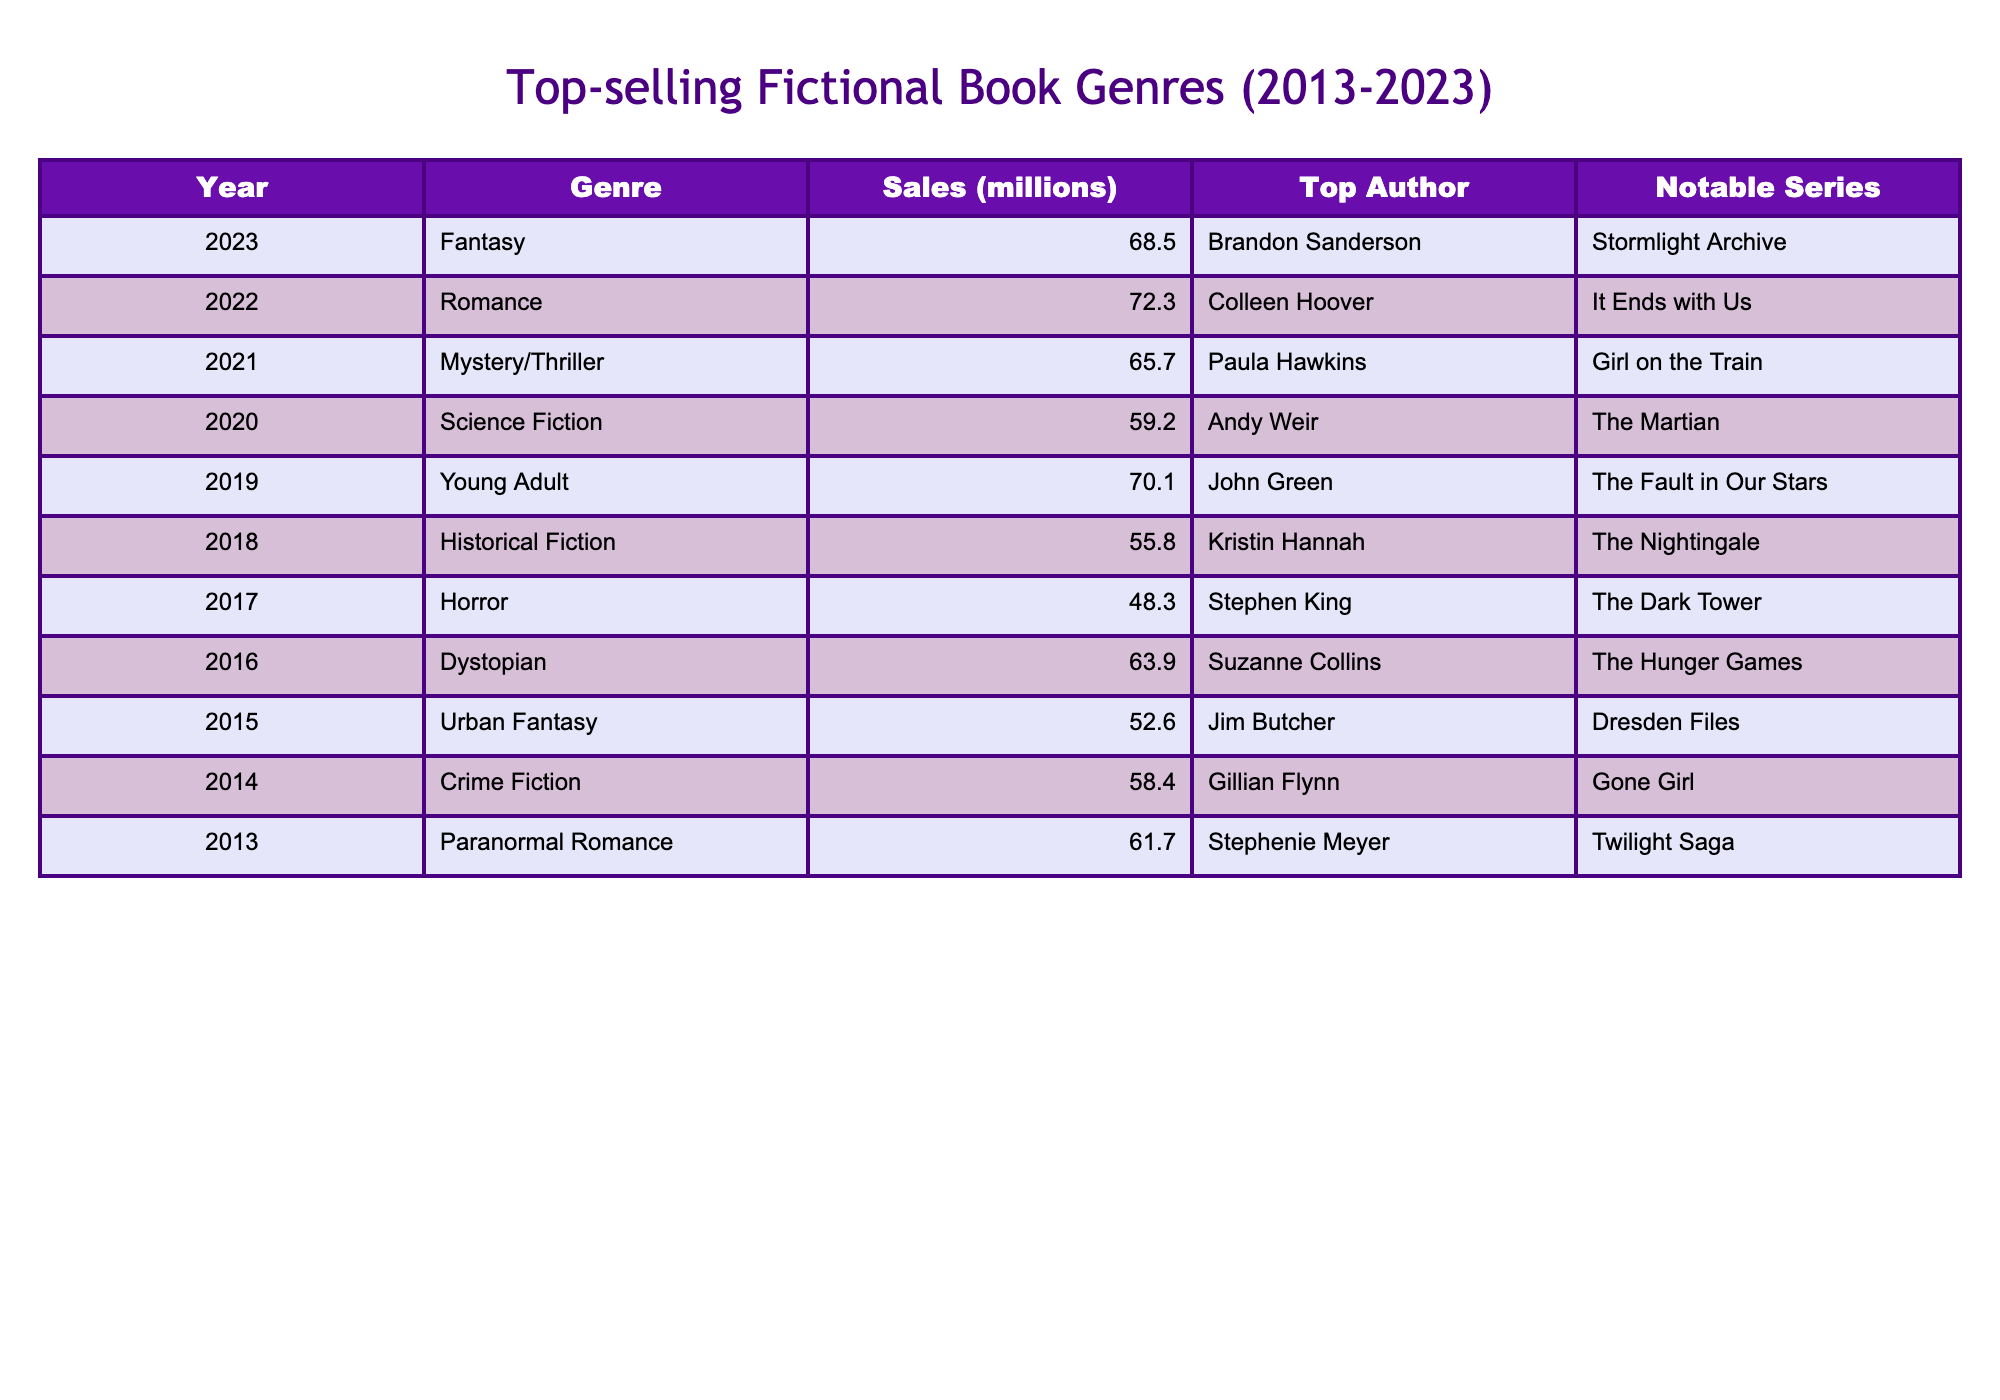What was the top-selling genre in 2023? The table shows that Fantasy was the top-selling genre in 2023 with sales of 68.5 million.
Answer: Fantasy Which genre had the highest sales in 2022? In 2022, Romance had the highest sales at 72.3 million, according to the table.
Answer: Romance How many million copies were sold in total across all years listed? The total sales can be calculated by adding all sales figures: 68.5 + 72.3 + 65.7 + 59.2 + 70.1 + 55.8 + 48.3 + 63.9 + 52.6 + 58.4 + 61.7 = 672.1 million.
Answer: 672.1 million Was there a noticeable increase in sales from 2020 to 2021? Comparing sales from 2020 (59.2 million) to 2021 (65.7 million), there was an increase of 6.5 million. This indicates a noticeable rise.
Answer: Yes Which genre had the lowest sales in the decade? The table indicates that Horror had the lowest sales at 48.3 million in 2017.
Answer: Horror What was the sales difference between the top-selling genre of 2023 and 2021? The difference can be calculated by subtracting 2021 sales (65.7 million) from 2023 sales (68.5 million), resulting in a difference of 2.8 million.
Answer: 2.8 million Which author had the top-selling book in 2019? In 2019, the table shows that John Green was the top author with the genre being Young Adult and sales at 70.1 million.
Answer: John Green What is the median sales figure for the years presented in the table? To find the median, we list the sales figures: [48.3, 52.6, 55.8, 59.2, 61.7, 63.9, 65.7, 68.5, 70.1, 72.3], which has 10 values. The median is the average of the 5th and 6th values: (61.7 + 63.9)/2 = 62.8 million.
Answer: 62.8 million Which years had sales above 60 million? The years with sales above 60 million are 2013, 2014, 2016, 2019, 2021, 2022, and 2023.
Answer: 7 years Was the 'Crime Fiction' genre more successful in 2014 or 'Dystopian' in 2016? Crime Fiction in 2014 had sales of 58.4 million, whereas Dystopian in 2016 had sales of 63.9 million. Therefore, Dystopian was more successful.
Answer: Dystopian was more successful 